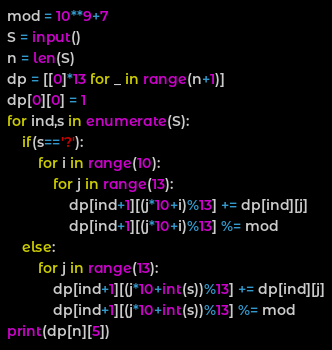Convert code to text. <code><loc_0><loc_0><loc_500><loc_500><_Python_>mod = 10**9+7
S = input()
n = len(S)
dp = [[0]*13 for _ in range(n+1)]
dp[0][0] = 1
for ind,s in enumerate(S):
    if(s=='?'):
        for i in range(10):
            for j in range(13):
                dp[ind+1][(j*10+i)%13] += dp[ind][j]
                dp[ind+1][(j*10+i)%13] %= mod
    else:
        for j in range(13):
            dp[ind+1][(j*10+int(s))%13] += dp[ind][j]
            dp[ind+1][(j*10+int(s))%13] %= mod
print(dp[n][5])</code> 